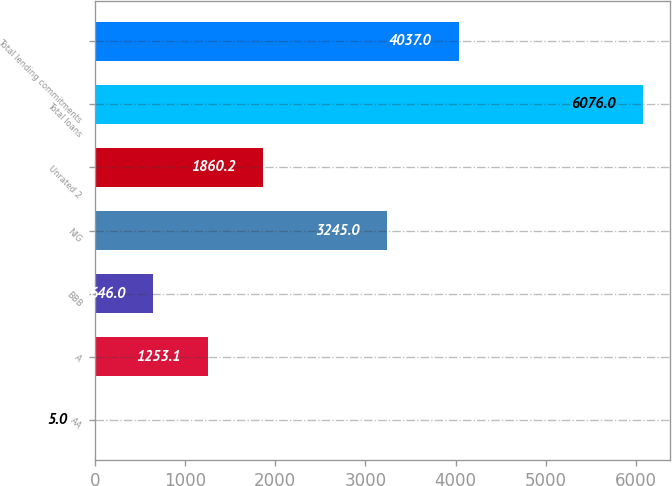Convert chart to OTSL. <chart><loc_0><loc_0><loc_500><loc_500><bar_chart><fcel>AA<fcel>A<fcel>BBB<fcel>NIG<fcel>Unrated 2<fcel>Total loans<fcel>Total lending commitments<nl><fcel>5<fcel>1253.1<fcel>646<fcel>3245<fcel>1860.2<fcel>6076<fcel>4037<nl></chart> 